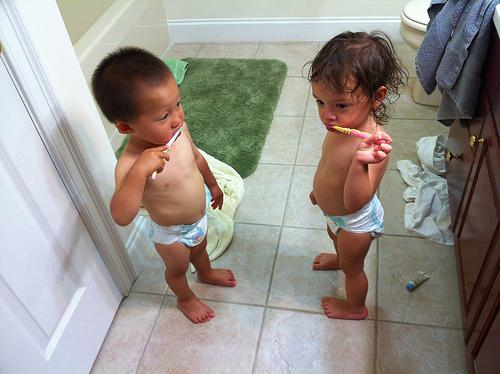Question: how many babies are brushing their teeth?
Choices:
A. 2.
B. 1.
C. 3.
D. 4.
Answer with the letter. Answer: A Question: who is brushing their teeth?
Choices:
A. Men.
B. Women.
C. Children.
D. Babies.
Answer with the letter. Answer: D Question: where are the kids standing?
Choices:
A. On asphalt.
B. On tile.
C. On dirt.
D. In a field.
Answer with the letter. Answer: B Question: where is the photo taken?
Choices:
A. Kitchen.
B. Bathroom.
C. Bedroom.
D. House.
Answer with the letter. Answer: B 